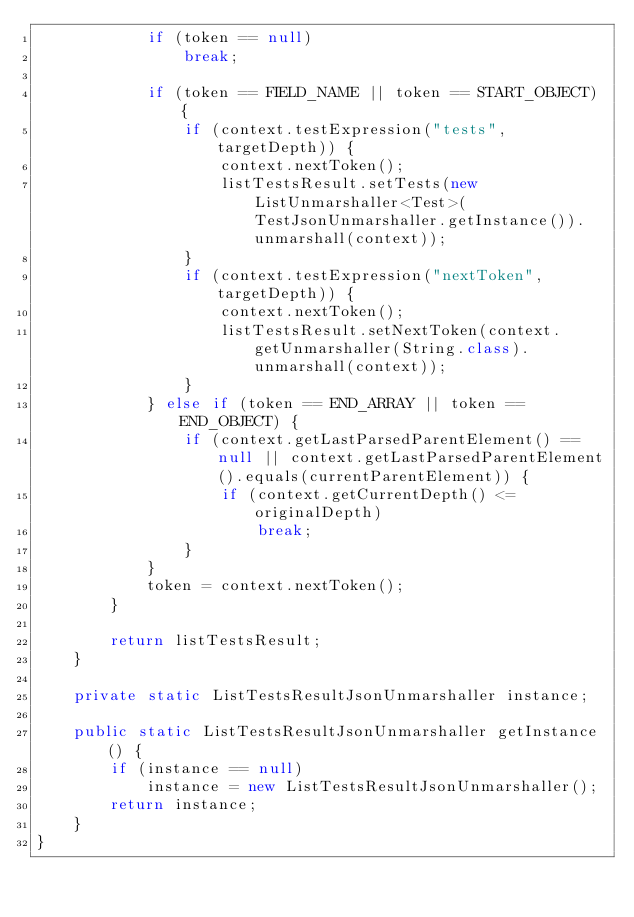<code> <loc_0><loc_0><loc_500><loc_500><_Java_>            if (token == null)
                break;

            if (token == FIELD_NAME || token == START_OBJECT) {
                if (context.testExpression("tests", targetDepth)) {
                    context.nextToken();
                    listTestsResult.setTests(new ListUnmarshaller<Test>(TestJsonUnmarshaller.getInstance()).unmarshall(context));
                }
                if (context.testExpression("nextToken", targetDepth)) {
                    context.nextToken();
                    listTestsResult.setNextToken(context.getUnmarshaller(String.class).unmarshall(context));
                }
            } else if (token == END_ARRAY || token == END_OBJECT) {
                if (context.getLastParsedParentElement() == null || context.getLastParsedParentElement().equals(currentParentElement)) {
                    if (context.getCurrentDepth() <= originalDepth)
                        break;
                }
            }
            token = context.nextToken();
        }

        return listTestsResult;
    }

    private static ListTestsResultJsonUnmarshaller instance;

    public static ListTestsResultJsonUnmarshaller getInstance() {
        if (instance == null)
            instance = new ListTestsResultJsonUnmarshaller();
        return instance;
    }
}
</code> 